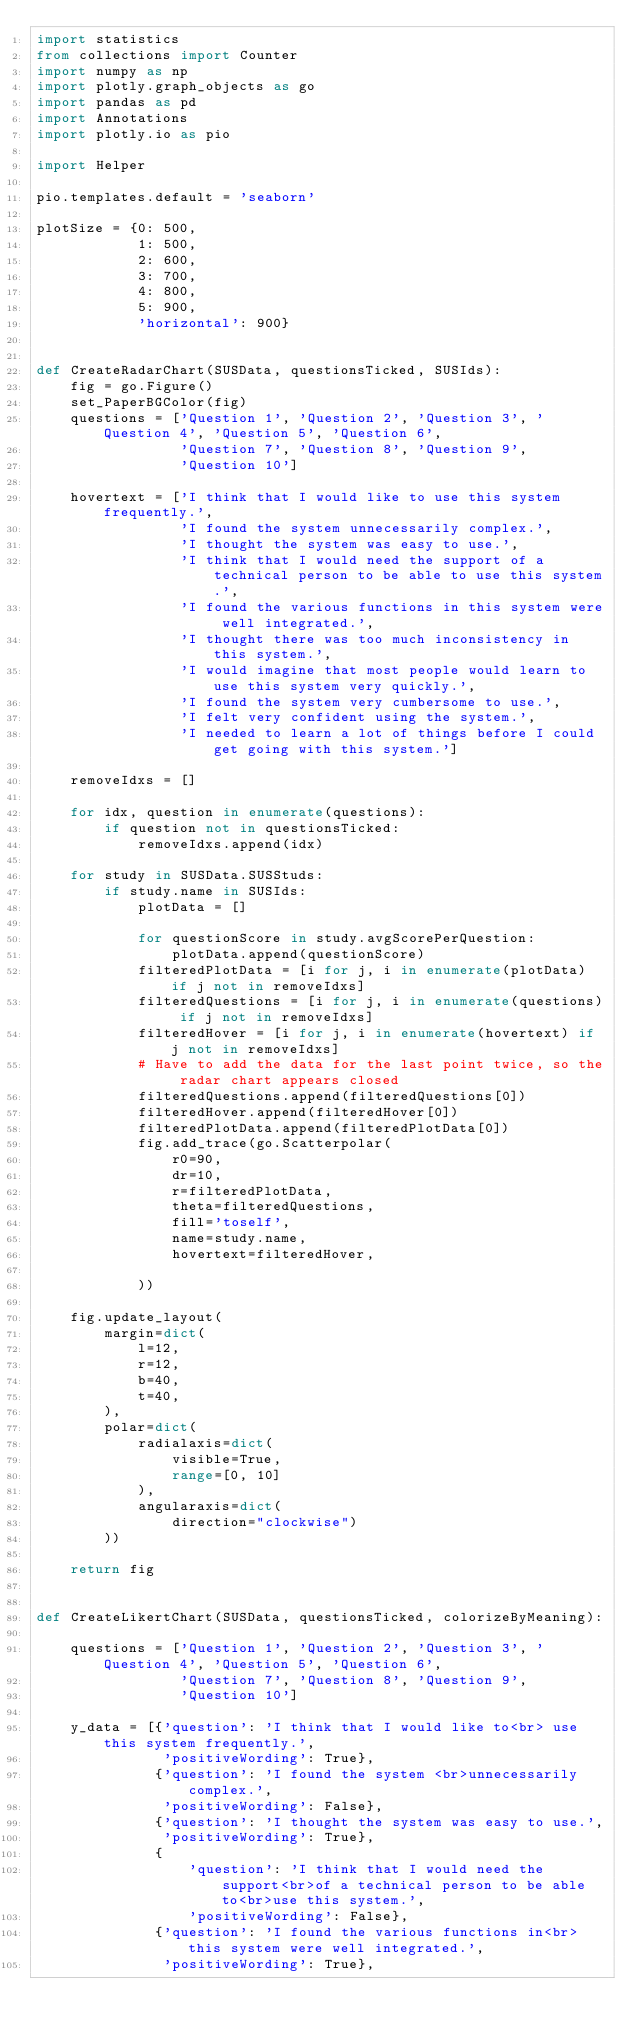<code> <loc_0><loc_0><loc_500><loc_500><_Python_>import statistics
from collections import Counter
import numpy as np
import plotly.graph_objects as go
import pandas as pd
import Annotations
import plotly.io as pio

import Helper

pio.templates.default = 'seaborn'

plotSize = {0: 500,
            1: 500,
            2: 600,
            3: 700,
            4: 800,
            5: 900,
            'horizontal': 900}


def CreateRadarChart(SUSData, questionsTicked, SUSIds):
    fig = go.Figure()
    set_PaperBGColor(fig)
    questions = ['Question 1', 'Question 2', 'Question 3', 'Question 4', 'Question 5', 'Question 6',
                 'Question 7', 'Question 8', 'Question 9',
                 'Question 10']

    hovertext = ['I think that I would like to use this system frequently.',
                 'I found the system unnecessarily complex.',
                 'I thought the system was easy to use.',
                 'I think that I would need the support of a technical person to be able to use this system.',
                 'I found the various functions in this system were well integrated.',
                 'I thought there was too much inconsistency in this system.',
                 'I would imagine that most people would learn to use this system very quickly.',
                 'I found the system very cumbersome to use.',
                 'I felt very confident using the system.',
                 'I needed to learn a lot of things before I could get going with this system.']

    removeIdxs = []

    for idx, question in enumerate(questions):
        if question not in questionsTicked:
            removeIdxs.append(idx)

    for study in SUSData.SUSStuds:
        if study.name in SUSIds:
            plotData = []

            for questionScore in study.avgScorePerQuestion:
                plotData.append(questionScore)
            filteredPlotData = [i for j, i in enumerate(plotData) if j not in removeIdxs]
            filteredQuestions = [i for j, i in enumerate(questions) if j not in removeIdxs]
            filteredHover = [i for j, i in enumerate(hovertext) if j not in removeIdxs]
            # Have to add the data for the last point twice, so the radar chart appears closed
            filteredQuestions.append(filteredQuestions[0])
            filteredHover.append(filteredHover[0])
            filteredPlotData.append(filteredPlotData[0])
            fig.add_trace(go.Scatterpolar(
                r0=90,
                dr=10,
                r=filteredPlotData,
                theta=filteredQuestions,
                fill='toself',
                name=study.name,
                hovertext=filteredHover,

            ))

    fig.update_layout(
        margin=dict(
            l=12,
            r=12,
            b=40,
            t=40,
        ),
        polar=dict(
            radialaxis=dict(
                visible=True,
                range=[0, 10]
            ),
            angularaxis=dict(
                direction="clockwise")
        ))

    return fig


def CreateLikertChart(SUSData, questionsTicked, colorizeByMeaning):

    questions = ['Question 1', 'Question 2', 'Question 3', 'Question 4', 'Question 5', 'Question 6',
                 'Question 7', 'Question 8', 'Question 9',
                 'Question 10']

    y_data = [{'question': 'I think that I would like to<br> use this system frequently.',
               'positiveWording': True},
              {'question': 'I found the system <br>unnecessarily complex.',
               'positiveWording': False},
              {'question': 'I thought the system was easy to use.',
               'positiveWording': True},
              {
                  'question': 'I think that I would need the support<br>of a technical person to be able to<br>use this system.',
                  'positiveWording': False},
              {'question': 'I found the various functions in<br> this system were well integrated.',
               'positiveWording': True},</code> 